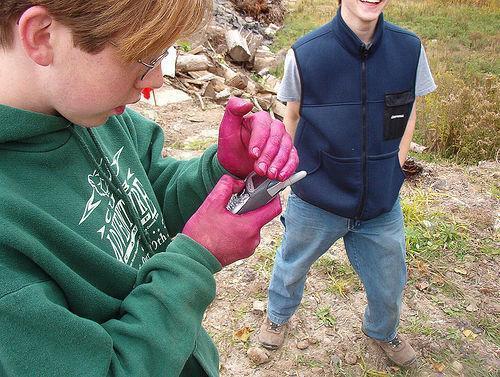How many people are there?
Give a very brief answer. 2. 